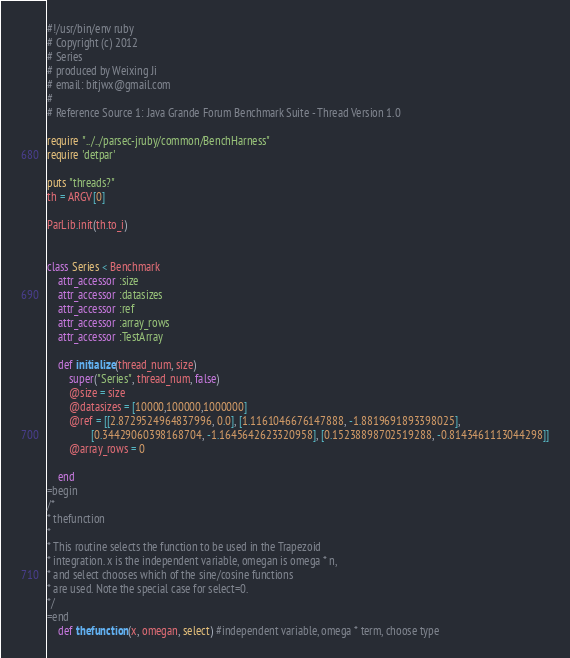Convert code to text. <code><loc_0><loc_0><loc_500><loc_500><_Ruby_>#!/usr/bin/env ruby
# Copyright (c) 2012 
# Series
# produced by Weixing Ji
# email: bitjwx@gmail.com
# 
# Reference Source 1: Java Grande Forum Benchmark Suite - Thread Version 1.0

require "../../parsec-jruby/common/BenchHarness"
require 'detpar'

puts "threads?"
th = ARGV[0]

ParLib.init(th.to_i)


class Series < Benchmark
    attr_accessor :size
    attr_accessor :datasizes
    attr_accessor :ref
    attr_accessor :array_rows
    attr_accessor :TestArray
    
    def initialize(thread_num, size)
        super("Series", thread_num, false)
        @size = size
        @datasizes = [10000,100000,1000000]
        @ref = [[2.8729524964837996, 0.0], [1.1161046676147888, -1.8819691893398025],
                [0.34429060398168704, -1.1645642623320958], [0.15238898702519288, -0.8143461113044298]]
        @array_rows = 0
        
    end
=begin
/*
* thefunction
*
* This routine selects the function to be used in the Trapezoid
* integration. x is the independent variable, omegan is omega * n,
* and select chooses which of the sine/cosine functions
* are used. Note the special case for select=0.
*/
=end
    def thefunction(x, omegan, select) #independent variable, omega * term, choose type</code> 